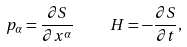<formula> <loc_0><loc_0><loc_500><loc_500>p _ { \alpha } = \frac { \partial S } { \partial x ^ { \alpha } } \, \quad \, H = - \frac { \partial S } { \partial t } ,</formula> 